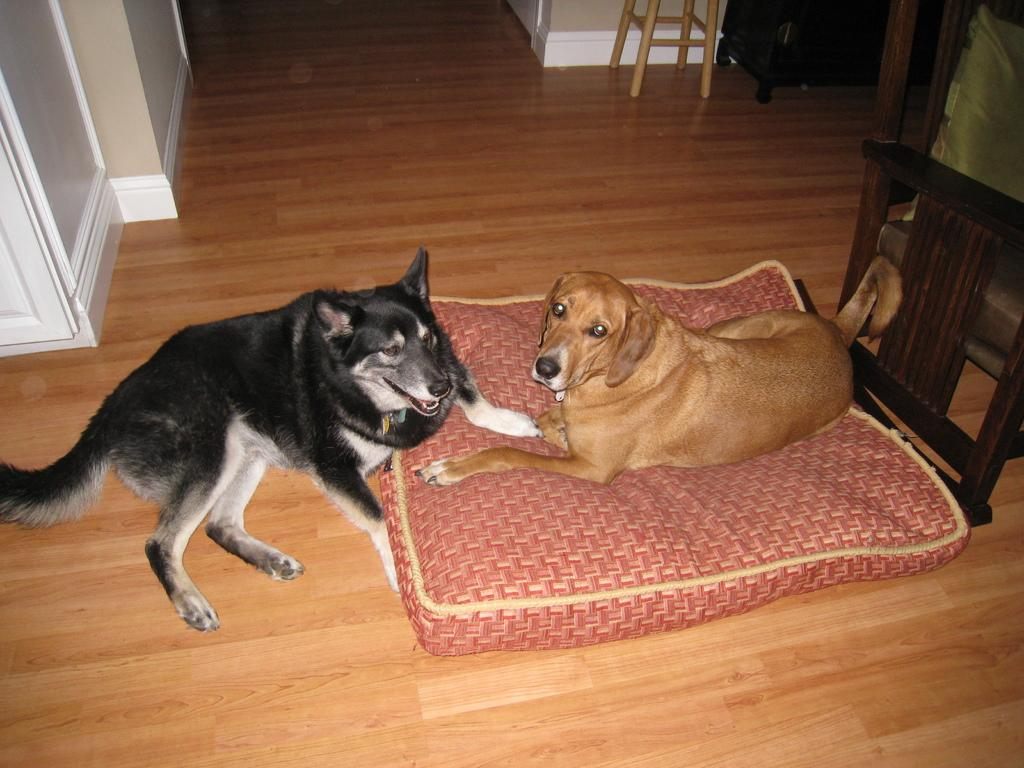What is the main subject of the image? The main subject of the image is a dog sitting on a small bed. Where is the dog located in the image? The dog is on the right side of the image. Can you describe the position of the second dog in the image? There is another dog sitting in front of the dog on the bed. What type of bulb is hanging above the dogs in the image? There is no bulb present in the image; it only features the two dogs. Can you describe the locket that the dog is wearing in the image? There is no locket visible on the dogs in the image. 